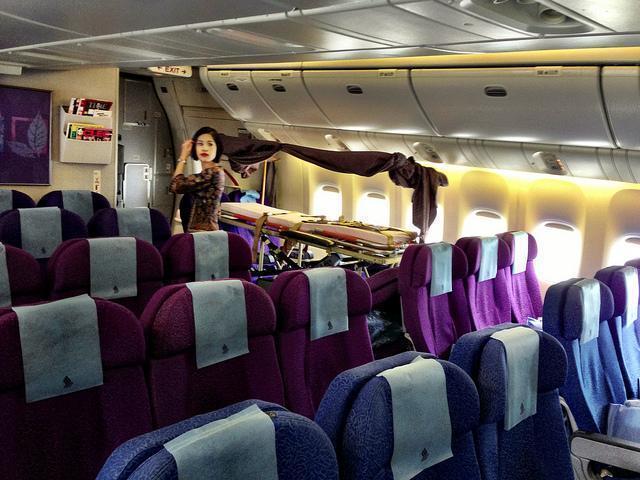Which country does this airline likely belong to?
Select the accurate response from the four choices given to answer the question.
Options: China, japan, singapore, thailand. Thailand. 